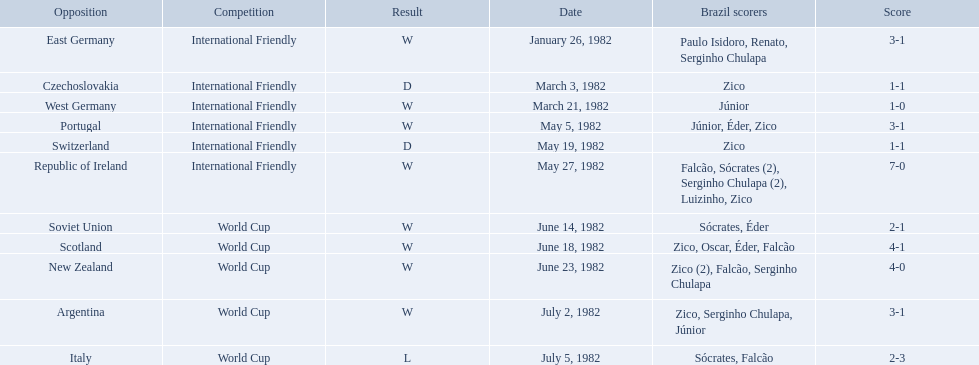How many goals did brazil score against the soviet union? 2-1. How many goals did brazil score against portugal? 3-1. Did brazil score more goals against portugal or the soviet union? Portugal. Parse the table in full. {'header': ['Opposition', 'Competition', 'Result', 'Date', 'Brazil scorers', 'Score'], 'rows': [['East Germany', 'International Friendly', 'W', 'January 26, 1982', 'Paulo Isidoro, Renato, Serginho Chulapa', '3-1'], ['Czechoslovakia', 'International Friendly', 'D', 'March 3, 1982', 'Zico', '1-1'], ['West Germany', 'International Friendly', 'W', 'March 21, 1982', 'Júnior', '1-0'], ['Portugal', 'International Friendly', 'W', 'May 5, 1982', 'Júnior, Éder, Zico', '3-1'], ['Switzerland', 'International Friendly', 'D', 'May 19, 1982', 'Zico', '1-1'], ['Republic of Ireland', 'International Friendly', 'W', 'May 27, 1982', 'Falcão, Sócrates (2), Serginho Chulapa (2), Luizinho, Zico', '7-0'], ['Soviet Union', 'World Cup', 'W', 'June 14, 1982', 'Sócrates, Éder', '2-1'], ['Scotland', 'World Cup', 'W', 'June 18, 1982', 'Zico, Oscar, Éder, Falcão', '4-1'], ['New Zealand', 'World Cup', 'W', 'June 23, 1982', 'Zico (2), Falcão, Serginho Chulapa', '4-0'], ['Argentina', 'World Cup', 'W', 'July 2, 1982', 'Zico, Serginho Chulapa, Júnior', '3-1'], ['Italy', 'World Cup', 'L', 'July 5, 1982', 'Sócrates, Falcão', '2-3']]} What are all the dates of games in 1982 in brazilian football? January 26, 1982, March 3, 1982, March 21, 1982, May 5, 1982, May 19, 1982, May 27, 1982, June 14, 1982, June 18, 1982, June 23, 1982, July 2, 1982, July 5, 1982. Which of these dates is at the top of the chart? January 26, 1982. 